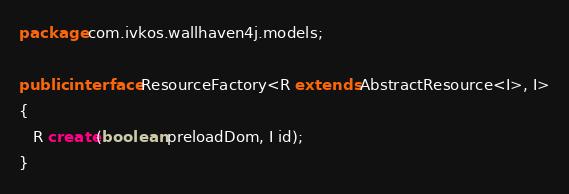<code> <loc_0><loc_0><loc_500><loc_500><_Java_>package com.ivkos.wallhaven4j.models;

public interface ResourceFactory<R extends AbstractResource<I>, I>
{
   R create(boolean preloadDom, I id);
}
</code> 